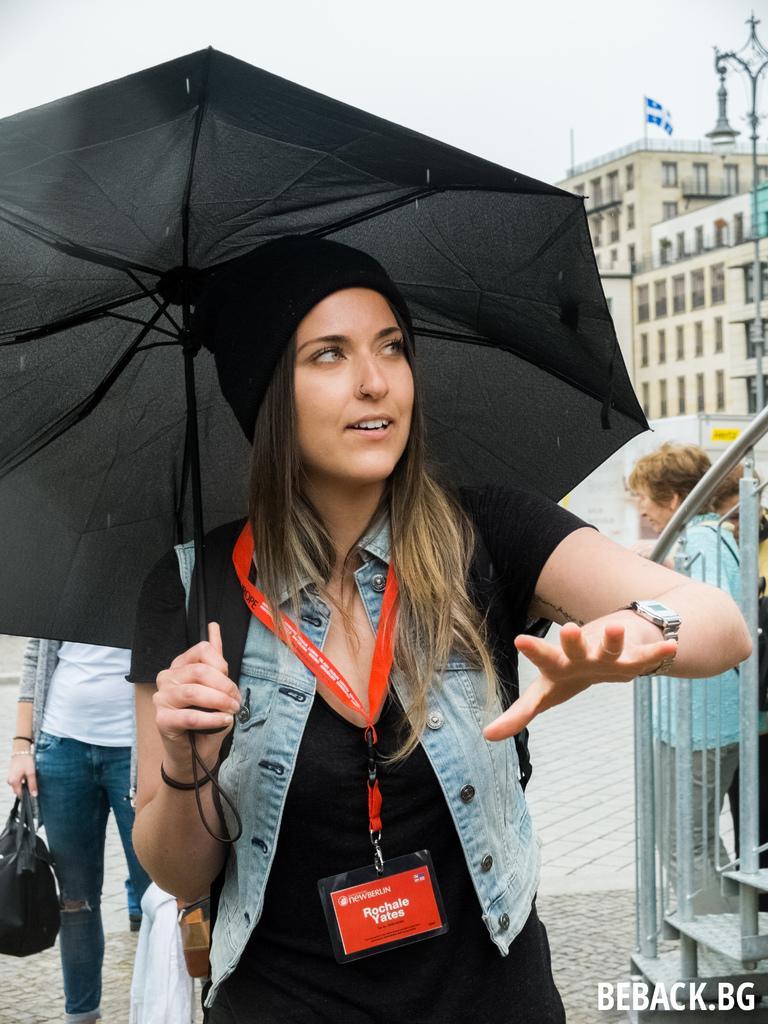Describe this image in one or two sentences. In this picture there is a woman who is wearing cap, jacket, watch and black dress. She is holding an umbrella. On the left there is another woman who is wearing, t- shirt, jeans and holding a black bag. On the right I can see the woman who is standing near to the stairs and fencing. In the background I can see the building and street lights. At the top of the building I can see the flag and railing. At the top I can see the sky and clouds. In the bottom right corner there is a watermark. 